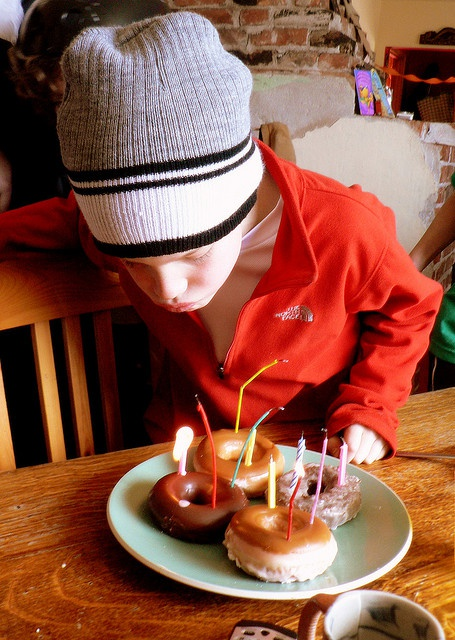Describe the objects in this image and their specific colors. I can see people in lavender, black, red, and maroon tones, dining table in lavender, brown, maroon, and black tones, chair in lavender, black, maroon, brown, and orange tones, donut in lavender, white, brown, red, and maroon tones, and cup in lavender, maroon, lightgray, and black tones in this image. 